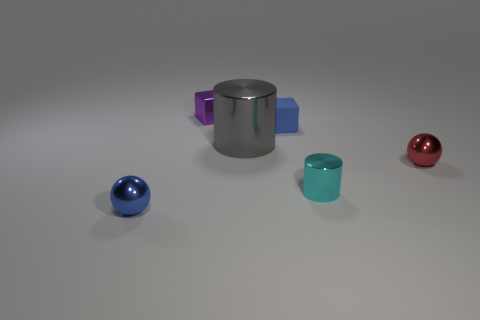Are there any other things that are the same material as the small blue cube?
Your answer should be very brief. No. The matte cube is what color?
Ensure brevity in your answer.  Blue. Is the size of the blue thing that is to the right of the purple block the same as the shiny cylinder behind the red metal thing?
Keep it short and to the point. No. What size is the shiny thing that is both on the right side of the large metallic thing and to the left of the tiny red sphere?
Provide a short and direct response. Small. What is the color of the other object that is the same shape as the big object?
Ensure brevity in your answer.  Cyan. Are there more things that are left of the big gray metallic object than small metallic spheres right of the tiny cyan object?
Make the answer very short. Yes. Is there a metallic sphere to the left of the thing behind the small blue rubber thing?
Provide a short and direct response. Yes. How many tiny rubber cubes are there?
Give a very brief answer. 1. Is the color of the matte cube the same as the small metal ball that is on the left side of the big gray metal thing?
Give a very brief answer. Yes. Is the number of large purple rubber cubes greater than the number of gray metallic cylinders?
Offer a terse response. No. 